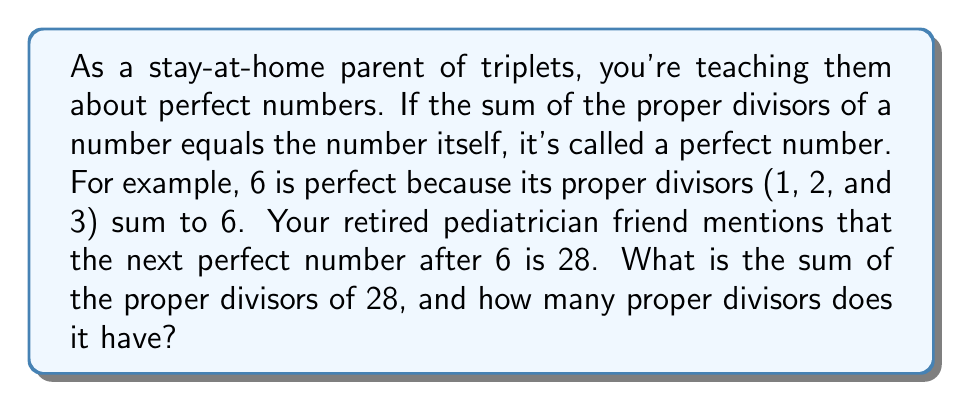Solve this math problem. Let's approach this step-by-step:

1) First, we need to find all the proper divisors of 28. Proper divisors are all positive divisors of a number other than the number itself.

2) To find the divisors, let's list out all numbers that divide 28 evenly:
   $1, 2, 4, 7, 14, 28$

3) Since we're only interested in proper divisors, we exclude 28 itself:
   $1, 2, 4, 7, 14$

4) Now, let's count these divisors:
   There are 5 proper divisors of 28.

5) To find the sum of these divisors:
   $1 + 2 + 4 + 7 + 14 = 28$

6) We can verify that 28 is indeed a perfect number because the sum of its proper divisors equals itself.

7) To double-check, we can use the formula for the sum of divisors:
   $$\sigma(n) = \sum_{d|n} d$$
   Where $d|n$ means $d$ divides $n$.

8) For 28: $\sigma(28) = 1 + 2 + 4 + 7 + 14 + 28 = 56$

9) The sum of proper divisors is $\sigma(28) - 28 = 56 - 28 = 28$

Therefore, the sum of the proper divisors of 28 is 28, and it has 5 proper divisors.
Answer: Sum: 28, Number of proper divisors: 5 